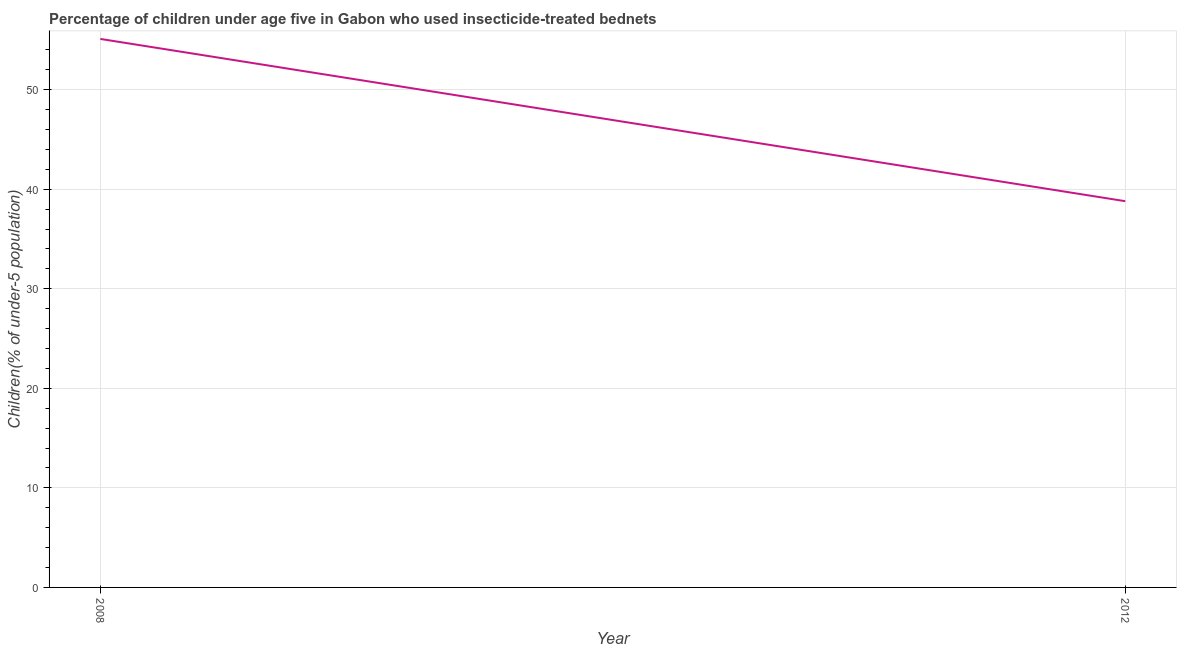What is the percentage of children who use of insecticide-treated bed nets in 2012?
Keep it short and to the point. 38.8. Across all years, what is the maximum percentage of children who use of insecticide-treated bed nets?
Your answer should be very brief. 55.1. Across all years, what is the minimum percentage of children who use of insecticide-treated bed nets?
Provide a succinct answer. 38.8. In which year was the percentage of children who use of insecticide-treated bed nets minimum?
Your answer should be compact. 2012. What is the sum of the percentage of children who use of insecticide-treated bed nets?
Your answer should be compact. 93.9. What is the difference between the percentage of children who use of insecticide-treated bed nets in 2008 and 2012?
Provide a succinct answer. 16.3. What is the average percentage of children who use of insecticide-treated bed nets per year?
Offer a very short reply. 46.95. What is the median percentage of children who use of insecticide-treated bed nets?
Provide a short and direct response. 46.95. Do a majority of the years between 2012 and 2008 (inclusive) have percentage of children who use of insecticide-treated bed nets greater than 52 %?
Give a very brief answer. No. What is the ratio of the percentage of children who use of insecticide-treated bed nets in 2008 to that in 2012?
Offer a very short reply. 1.42. In how many years, is the percentage of children who use of insecticide-treated bed nets greater than the average percentage of children who use of insecticide-treated bed nets taken over all years?
Make the answer very short. 1. Does the percentage of children who use of insecticide-treated bed nets monotonically increase over the years?
Ensure brevity in your answer.  No. How many years are there in the graph?
Your answer should be compact. 2. What is the difference between two consecutive major ticks on the Y-axis?
Your answer should be very brief. 10. Does the graph contain any zero values?
Give a very brief answer. No. Does the graph contain grids?
Your answer should be very brief. Yes. What is the title of the graph?
Your response must be concise. Percentage of children under age five in Gabon who used insecticide-treated bednets. What is the label or title of the X-axis?
Offer a terse response. Year. What is the label or title of the Y-axis?
Your answer should be compact. Children(% of under-5 population). What is the Children(% of under-5 population) of 2008?
Make the answer very short. 55.1. What is the Children(% of under-5 population) in 2012?
Your answer should be compact. 38.8. What is the difference between the Children(% of under-5 population) in 2008 and 2012?
Your answer should be very brief. 16.3. What is the ratio of the Children(% of under-5 population) in 2008 to that in 2012?
Offer a very short reply. 1.42. 